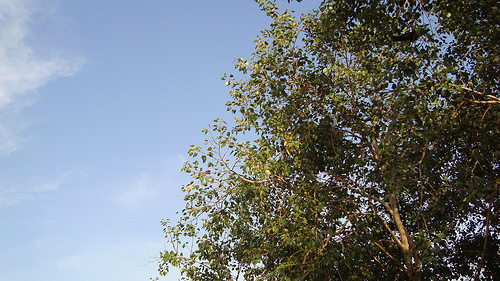<image>
Can you confirm if the cloud is behind the trees? Yes. From this viewpoint, the cloud is positioned behind the trees, with the trees partially or fully occluding the cloud. Is the tree on the cloud? No. The tree is not positioned on the cloud. They may be near each other, but the tree is not supported by or resting on top of the cloud. 